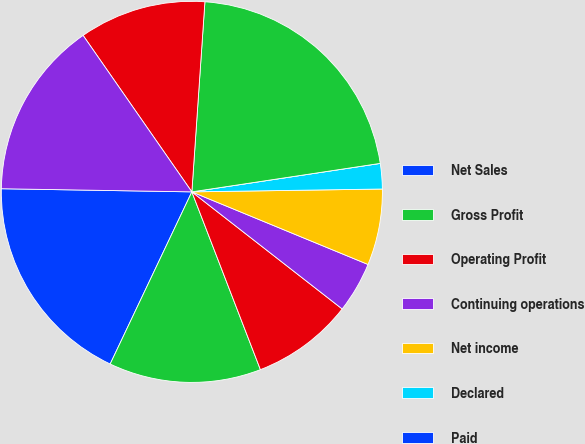<chart> <loc_0><loc_0><loc_500><loc_500><pie_chart><fcel>Net Sales<fcel>Gross Profit<fcel>Operating Profit<fcel>Continuing operations<fcel>Net income<fcel>Declared<fcel>Paid<fcel>Total Assets<fcel>Long-Term Debt<fcel>Stockholders' Equity<nl><fcel>18.21%<fcel>12.91%<fcel>8.61%<fcel>4.31%<fcel>6.46%<fcel>2.15%<fcel>0.0%<fcel>21.52%<fcel>10.76%<fcel>15.07%<nl></chart> 